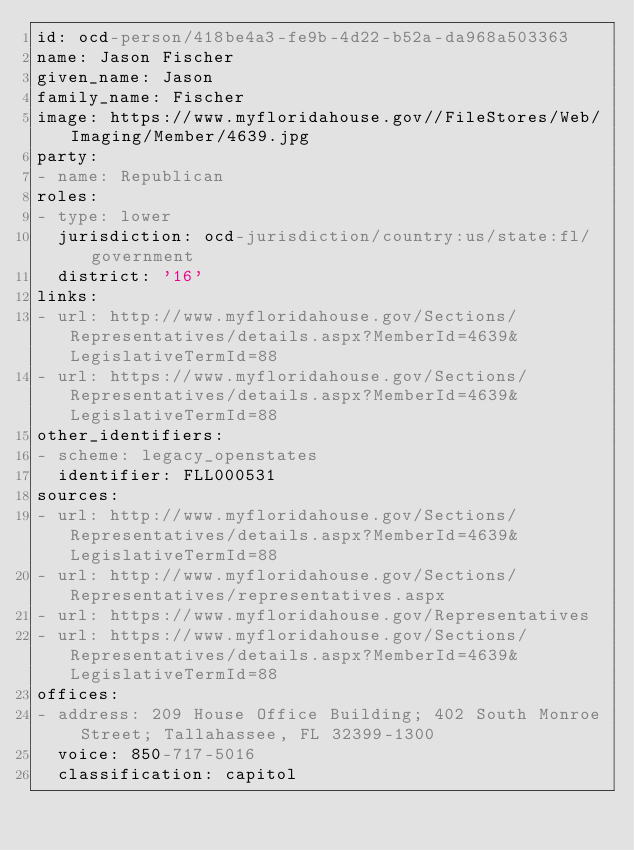<code> <loc_0><loc_0><loc_500><loc_500><_YAML_>id: ocd-person/418be4a3-fe9b-4d22-b52a-da968a503363
name: Jason Fischer
given_name: Jason
family_name: Fischer
image: https://www.myfloridahouse.gov//FileStores/Web/Imaging/Member/4639.jpg
party:
- name: Republican
roles:
- type: lower
  jurisdiction: ocd-jurisdiction/country:us/state:fl/government
  district: '16'
links:
- url: http://www.myfloridahouse.gov/Sections/Representatives/details.aspx?MemberId=4639&LegislativeTermId=88
- url: https://www.myfloridahouse.gov/Sections/Representatives/details.aspx?MemberId=4639&LegislativeTermId=88
other_identifiers:
- scheme: legacy_openstates
  identifier: FLL000531
sources:
- url: http://www.myfloridahouse.gov/Sections/Representatives/details.aspx?MemberId=4639&LegislativeTermId=88
- url: http://www.myfloridahouse.gov/Sections/Representatives/representatives.aspx
- url: https://www.myfloridahouse.gov/Representatives
- url: https://www.myfloridahouse.gov/Sections/Representatives/details.aspx?MemberId=4639&LegislativeTermId=88
offices:
- address: 209 House Office Building; 402 South Monroe Street; Tallahassee, FL 32399-1300
  voice: 850-717-5016
  classification: capitol</code> 